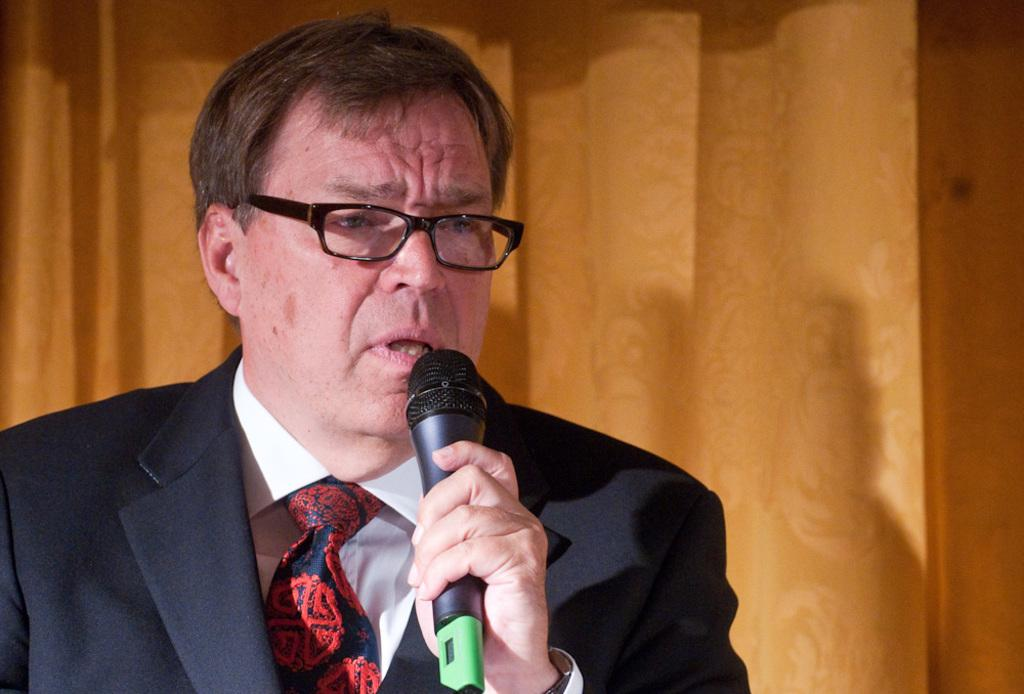What is the main subject of the image? The main subject of the image is a man. What is the man wearing in the image? The man is wearing a suit and spectacles in the image. What object is the man holding in his hand? The man is holding a microphone in his hand. What type of chalk is the man using to draw on the wall in the image? There is no chalk or drawing on the wall present in the image. What thrilling activity is the man participating in while holding the microphone in the image? The image does not provide information about any thrilling activity; it simply shows a man holding a microphone. 